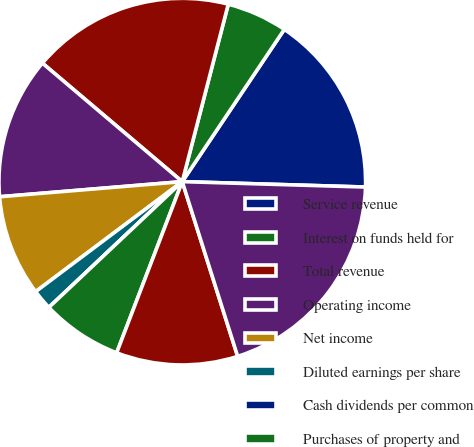Convert chart to OTSL. <chart><loc_0><loc_0><loc_500><loc_500><pie_chart><fcel>Service revenue<fcel>Interest on funds held for<fcel>Total revenue<fcel>Operating income<fcel>Net income<fcel>Diluted earnings per share<fcel>Cash dividends per common<fcel>Purchases of property and<fcel>Cash and total corporate<fcel>Total assets<nl><fcel>16.07%<fcel>5.36%<fcel>17.85%<fcel>12.5%<fcel>8.93%<fcel>1.79%<fcel>0.0%<fcel>7.14%<fcel>10.71%<fcel>19.64%<nl></chart> 